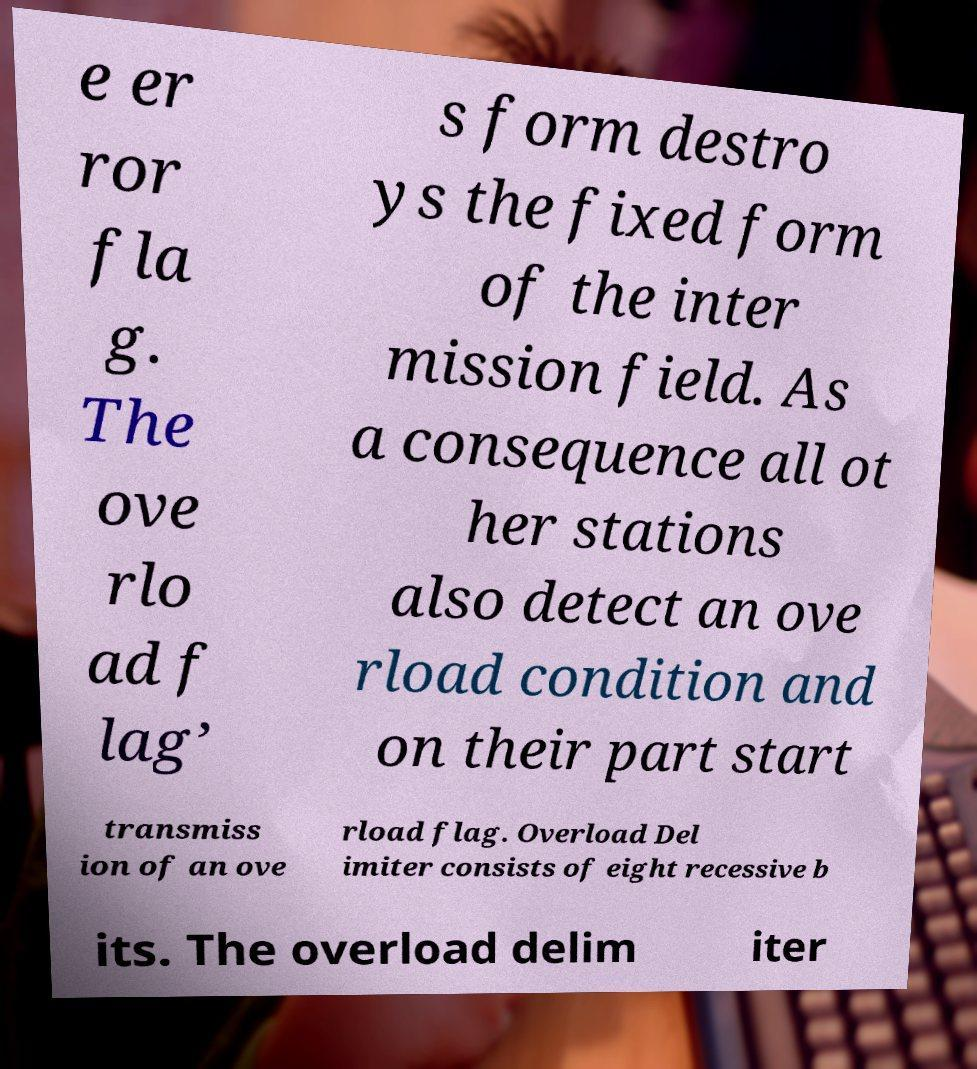Could you assist in decoding the text presented in this image and type it out clearly? e er ror fla g. The ove rlo ad f lag’ s form destro ys the fixed form of the inter mission field. As a consequence all ot her stations also detect an ove rload condition and on their part start transmiss ion of an ove rload flag. Overload Del imiter consists of eight recessive b its. The overload delim iter 